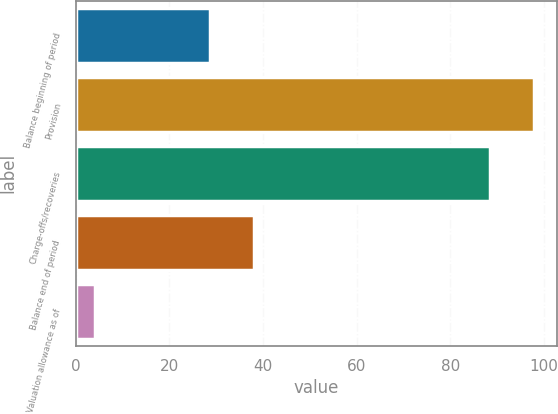Convert chart to OTSL. <chart><loc_0><loc_0><loc_500><loc_500><bar_chart><fcel>Balance beginning of period<fcel>Provision<fcel>Charge-offs/recoveries<fcel>Balance end of period<fcel>Valuation allowance as of<nl><fcel>28.7<fcel>97.95<fcel>88.6<fcel>38.05<fcel>4.1<nl></chart> 